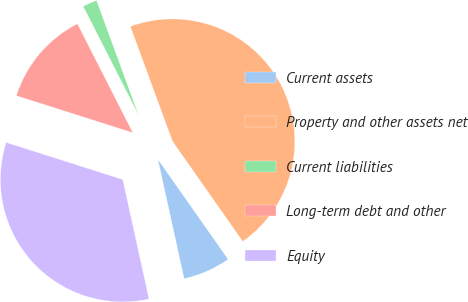Convert chart to OTSL. <chart><loc_0><loc_0><loc_500><loc_500><pie_chart><fcel>Current assets<fcel>Property and other assets net<fcel>Current liabilities<fcel>Long-term debt and other<fcel>Equity<nl><fcel>6.3%<fcel>45.86%<fcel>1.9%<fcel>12.6%<fcel>33.35%<nl></chart> 